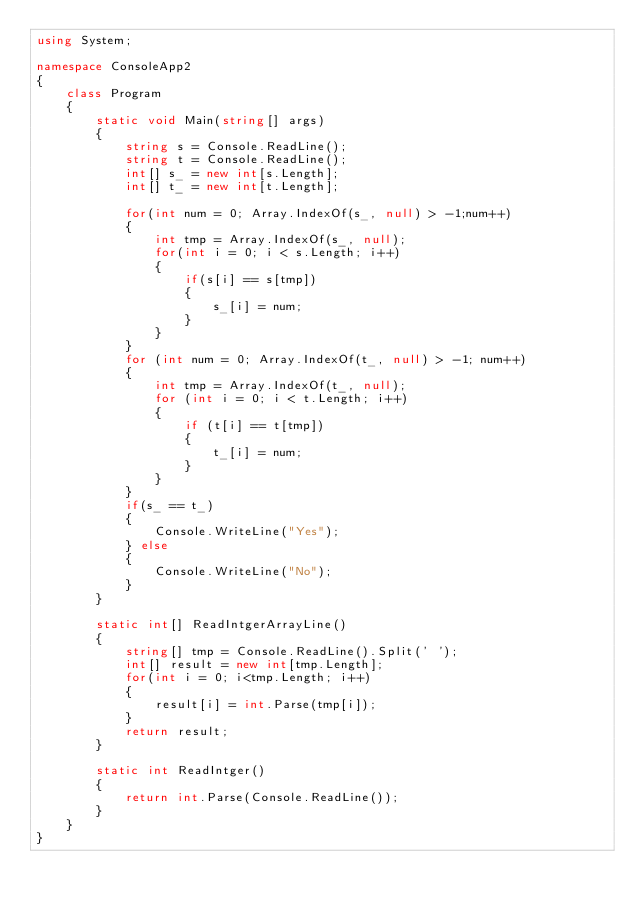<code> <loc_0><loc_0><loc_500><loc_500><_C#_>using System;

namespace ConsoleApp2
{
    class Program
    {
        static void Main(string[] args)
        {
            string s = Console.ReadLine();
            string t = Console.ReadLine();
            int[] s_ = new int[s.Length];
            int[] t_ = new int[t.Length];

            for(int num = 0; Array.IndexOf(s_, null) > -1;num++)
            {
                int tmp = Array.IndexOf(s_, null);
                for(int i = 0; i < s.Length; i++)
                {
                    if(s[i] == s[tmp])
                    {
                        s_[i] = num;
                    }
                }
            }
            for (int num = 0; Array.IndexOf(t_, null) > -1; num++)
            {
                int tmp = Array.IndexOf(t_, null);
                for (int i = 0; i < t.Length; i++)
                {
                    if (t[i] == t[tmp])
                    {
                        t_[i] = num;
                    }
                }
            }
            if(s_ == t_)
            {
                Console.WriteLine("Yes");
            } else
            {
                Console.WriteLine("No");
            }
        }

        static int[] ReadIntgerArrayLine()
        {
            string[] tmp = Console.ReadLine().Split(' ');
            int[] result = new int[tmp.Length];
            for(int i = 0; i<tmp.Length; i++)
            {
                result[i] = int.Parse(tmp[i]);
            }
            return result;
        }

        static int ReadIntger()
        {
            return int.Parse(Console.ReadLine());
        }
    }
}
</code> 